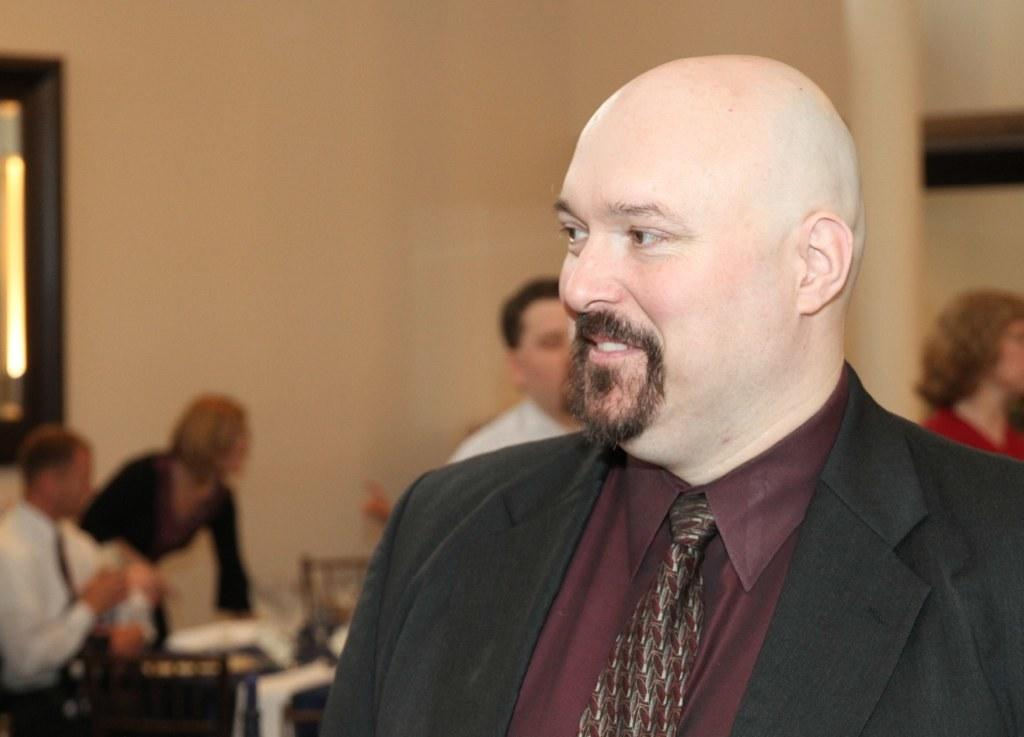What is the person in the image wearing? The person in the image is wearing a black suit. What can be seen in the background of the image? There are many people and a wall in the background of the image. How is the background of the image depicted? The background is blurred. What emotion is the person in the bed feeling in the image? There is no person in a bed present in the image, and therefore no emotion can be attributed to them. 